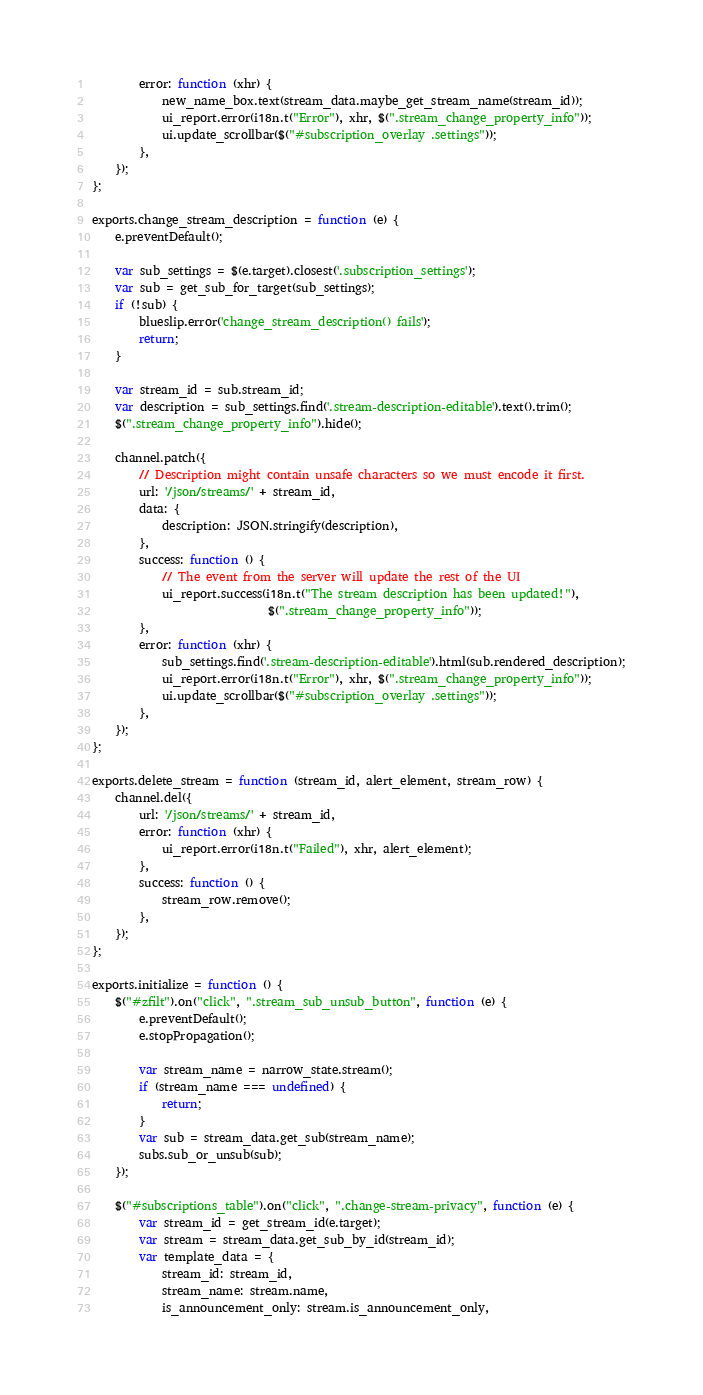<code> <loc_0><loc_0><loc_500><loc_500><_JavaScript_>        error: function (xhr) {
            new_name_box.text(stream_data.maybe_get_stream_name(stream_id));
            ui_report.error(i18n.t("Error"), xhr, $(".stream_change_property_info"));
            ui.update_scrollbar($("#subscription_overlay .settings"));
        },
    });
};

exports.change_stream_description = function (e) {
    e.preventDefault();

    var sub_settings = $(e.target).closest('.subscription_settings');
    var sub = get_sub_for_target(sub_settings);
    if (!sub) {
        blueslip.error('change_stream_description() fails');
        return;
    }

    var stream_id = sub.stream_id;
    var description = sub_settings.find('.stream-description-editable').text().trim();
    $(".stream_change_property_info").hide();

    channel.patch({
        // Description might contain unsafe characters so we must encode it first.
        url: '/json/streams/' + stream_id,
        data: {
            description: JSON.stringify(description),
        },
        success: function () {
            // The event from the server will update the rest of the UI
            ui_report.success(i18n.t("The stream description has been updated!"),
                              $(".stream_change_property_info"));
        },
        error: function (xhr) {
            sub_settings.find('.stream-description-editable').html(sub.rendered_description);
            ui_report.error(i18n.t("Error"), xhr, $(".stream_change_property_info"));
            ui.update_scrollbar($("#subscription_overlay .settings"));
        },
    });
};

exports.delete_stream = function (stream_id, alert_element, stream_row) {
    channel.del({
        url: '/json/streams/' + stream_id,
        error: function (xhr) {
            ui_report.error(i18n.t("Failed"), xhr, alert_element);
        },
        success: function () {
            stream_row.remove();
        },
    });
};

exports.initialize = function () {
    $("#zfilt").on("click", ".stream_sub_unsub_button", function (e) {
        e.preventDefault();
        e.stopPropagation();

        var stream_name = narrow_state.stream();
        if (stream_name === undefined) {
            return;
        }
        var sub = stream_data.get_sub(stream_name);
        subs.sub_or_unsub(sub);
    });

    $("#subscriptions_table").on("click", ".change-stream-privacy", function (e) {
        var stream_id = get_stream_id(e.target);
        var stream = stream_data.get_sub_by_id(stream_id);
        var template_data = {
            stream_id: stream_id,
            stream_name: stream.name,
            is_announcement_only: stream.is_announcement_only,</code> 